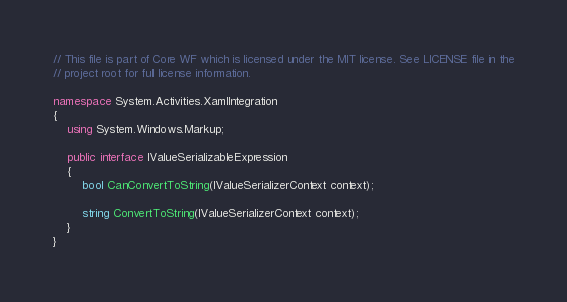Convert code to text. <code><loc_0><loc_0><loc_500><loc_500><_C#_>// This file is part of Core WF which is licensed under the MIT license. See LICENSE file in the
// project root for full license information.

namespace System.Activities.XamlIntegration
{
    using System.Windows.Markup;

    public interface IValueSerializableExpression
    {
        bool CanConvertToString(IValueSerializerContext context);

        string ConvertToString(IValueSerializerContext context);
    }
}
</code> 